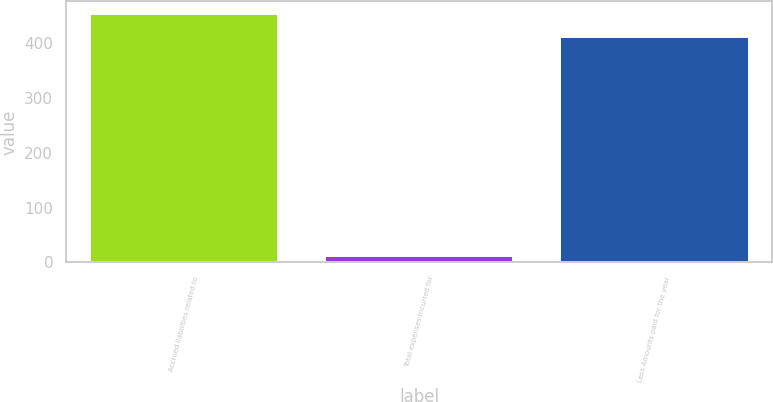Convert chart to OTSL. <chart><loc_0><loc_0><loc_500><loc_500><bar_chart><fcel>Accrued liabilities related to<fcel>Total expenses incurred for<fcel>Less Amounts paid for the year<nl><fcel>452.8<fcel>11<fcel>410<nl></chart> 